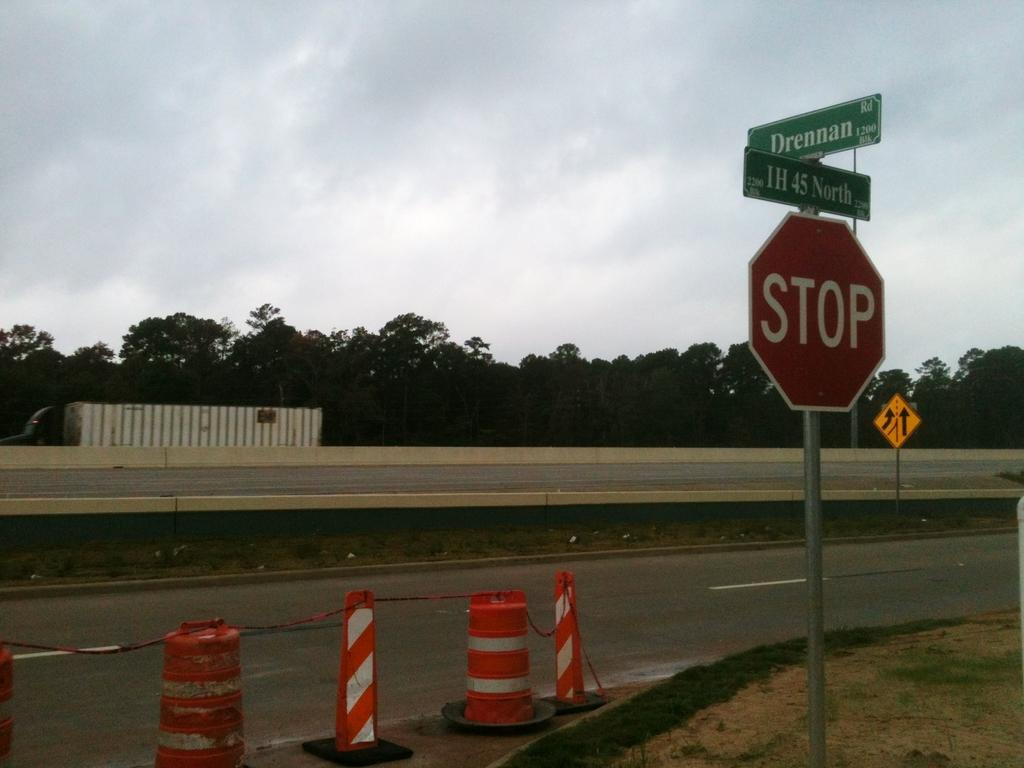<image>
Describe the image concisely. The road with orange cones and a green street sign with Drennan in white lettering. 